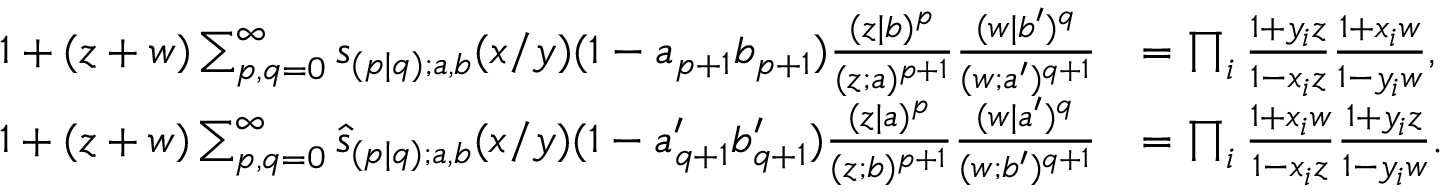<formula> <loc_0><loc_0><loc_500><loc_500>\begin{array} { r l } { 1 + ( z + w ) \sum _ { p , q = 0 } ^ { \infty } s _ { ( p | q ) ; a , b } ( x / y ) ( 1 - a _ { p + 1 } b _ { p + 1 } ) \frac { ( z | b ) ^ { p } } { ( z ; a ) ^ { p + 1 } } \frac { ( w | b ^ { \prime } ) ^ { q } } { ( w ; a ^ { \prime } ) ^ { q + 1 } } } & { = \prod _ { i } \frac { 1 + y _ { i } z } { 1 - x _ { i } z } \frac { 1 + x _ { i } w } { 1 - y _ { i } w } , } \\ { 1 + ( z + w ) \sum _ { p , q = 0 } ^ { \infty } \widehat { s } _ { ( p | q ) ; a , b } ( x / y ) ( 1 - a _ { q + 1 } ^ { \prime } b _ { q + 1 } ^ { \prime } ) \frac { ( z | a ) ^ { p } } { ( z ; b ) ^ { p + 1 } } \frac { ( w | a ^ { \prime } ) ^ { q } } { ( w ; b ^ { \prime } ) ^ { q + 1 } } } & { = \prod _ { i } \frac { 1 + x _ { i } w } { 1 - x _ { i } z } \frac { 1 + y _ { i } z } { 1 - y _ { i } w } . } \end{array}</formula> 